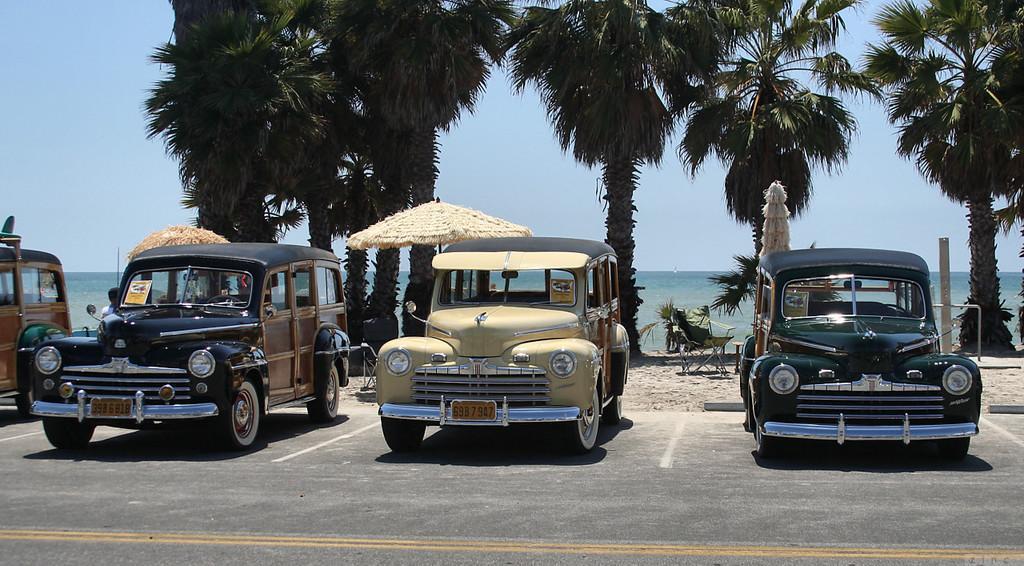Could you give a brief overview of what you see in this image? In this image few vehicles are on the road. There is a chair on the land. Beside the chair there is a table. An umbrella is behind the vehicle. Background there are trees. Behind there is water. Top of the image there is sky. A person is standing beside the vehicle. 